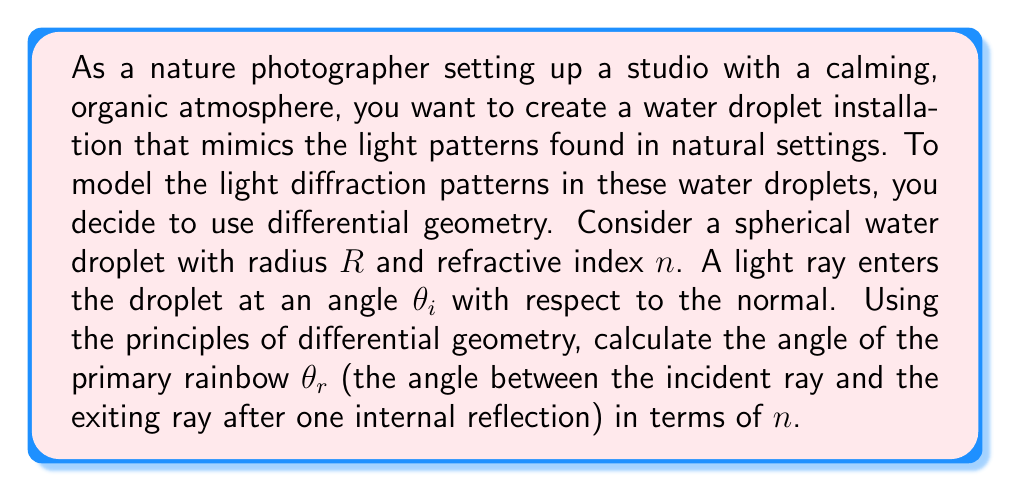Provide a solution to this math problem. To solve this problem, we'll use differential geometry to model the path of light through the water droplet:

1) First, we need to understand that the surface of the water droplet can be modeled as a 2-dimensional manifold embedded in 3D space. The path of light can be described as a geodesic on this manifold.

2) When light enters the droplet, it refracts according to Snell's law:

   $$\frac{\sin(\theta_i)}{\sin(\theta_t)} = n$$

   where $\theta_t$ is the angle of the transmitted ray inside the droplet.

3) The light then travels through the droplet, reflects off the back surface, and exits the droplet. The total deflection angle $\theta_d$ is given by:

   $$\theta_d = 2\theta_i - 4\theta_t + \pi$$

4) The rainbow angle $\theta_r$ occurs when $\frac{d\theta_d}{d\theta_i} = 0$. This condition gives us:

   $$\cos(\theta_i) = \frac{\sqrt{n^2-1}}{3}$$

5) Substituting this back into Snell's law:

   $$\sin(\theta_t) = \frac{\sin(\theta_i)}{n} = \frac{\sqrt{n^2-1}}{n\sqrt{3}}$$

6) The rainbow angle $\theta_r$ is then:

   $$\theta_r = 4\theta_t - 2\theta_i$$

7) Substituting the values we found:

   $$\theta_r = 4\arcsin(\frac{\sqrt{n^2-1}}{n\sqrt{3}}) - 2\arccos(\frac{\sqrt{n^2-1}}{3})$$

This equation gives us the rainbow angle in terms of the refractive index $n$.
Answer: $$\theta_r = 4\arcsin(\frac{\sqrt{n^2-1}}{n\sqrt{3}}) - 2\arccos(\frac{\sqrt{n^2-1}}{3})$$ 